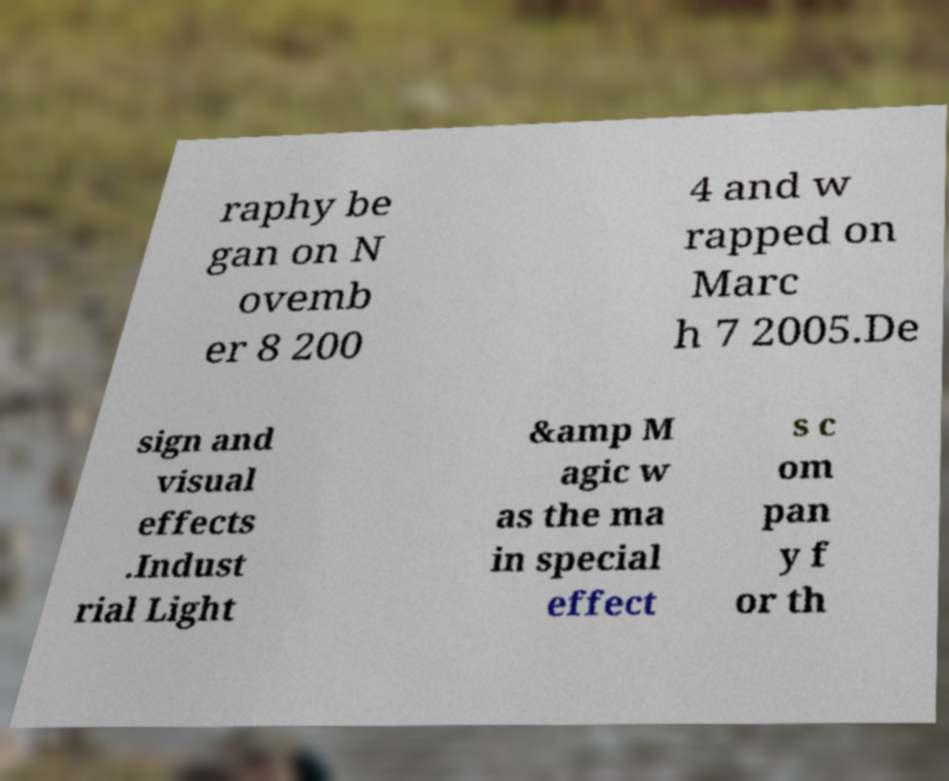What messages or text are displayed in this image? I need them in a readable, typed format. raphy be gan on N ovemb er 8 200 4 and w rapped on Marc h 7 2005.De sign and visual effects .Indust rial Light &amp M agic w as the ma in special effect s c om pan y f or th 